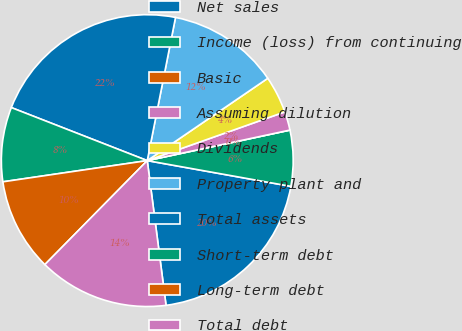Convert chart to OTSL. <chart><loc_0><loc_0><loc_500><loc_500><pie_chart><fcel>Net sales<fcel>Income (loss) from continuing<fcel>Basic<fcel>Assuming dilution<fcel>Dividends<fcel>Property plant and<fcel>Total assets<fcel>Short-term debt<fcel>Long-term debt<fcel>Total debt<nl><fcel>20.12%<fcel>6.18%<fcel>0.0%<fcel>2.06%<fcel>4.12%<fcel>12.36%<fcel>22.18%<fcel>8.24%<fcel>10.3%<fcel>14.43%<nl></chart> 